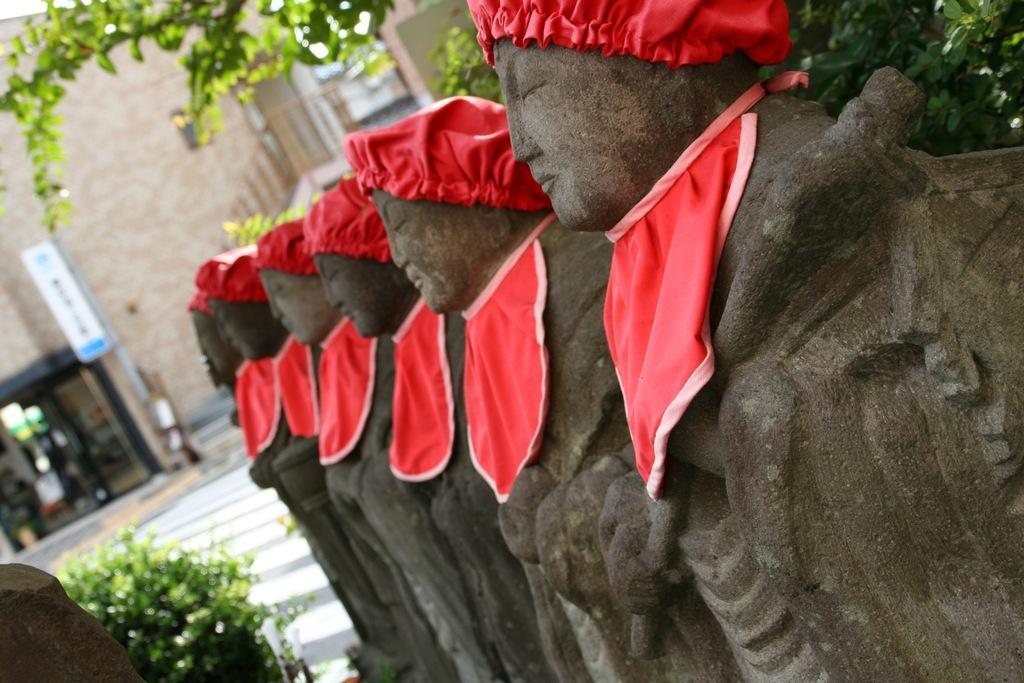In one or two sentences, can you explain what this image depicts? In this picture we can see statues in the front, on the right side and left side there are plants, there is a building in the background, we can also see a board and a glass in the background. 